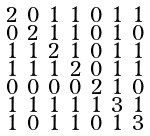Convert formula to latex. <formula><loc_0><loc_0><loc_500><loc_500>\begin{smallmatrix} 2 & 0 & 1 & 1 & 0 & 1 & 1 \\ 0 & 2 & 1 & 1 & 0 & 1 & 0 \\ 1 & 1 & 2 & 1 & 0 & 1 & 1 \\ 1 & 1 & 1 & 2 & 0 & 1 & 1 \\ 0 & 0 & 0 & 0 & 2 & 1 & 0 \\ 1 & 1 & 1 & 1 & 1 & 3 & 1 \\ 1 & 0 & 1 & 1 & 0 & 1 & 3 \end{smallmatrix}</formula> 